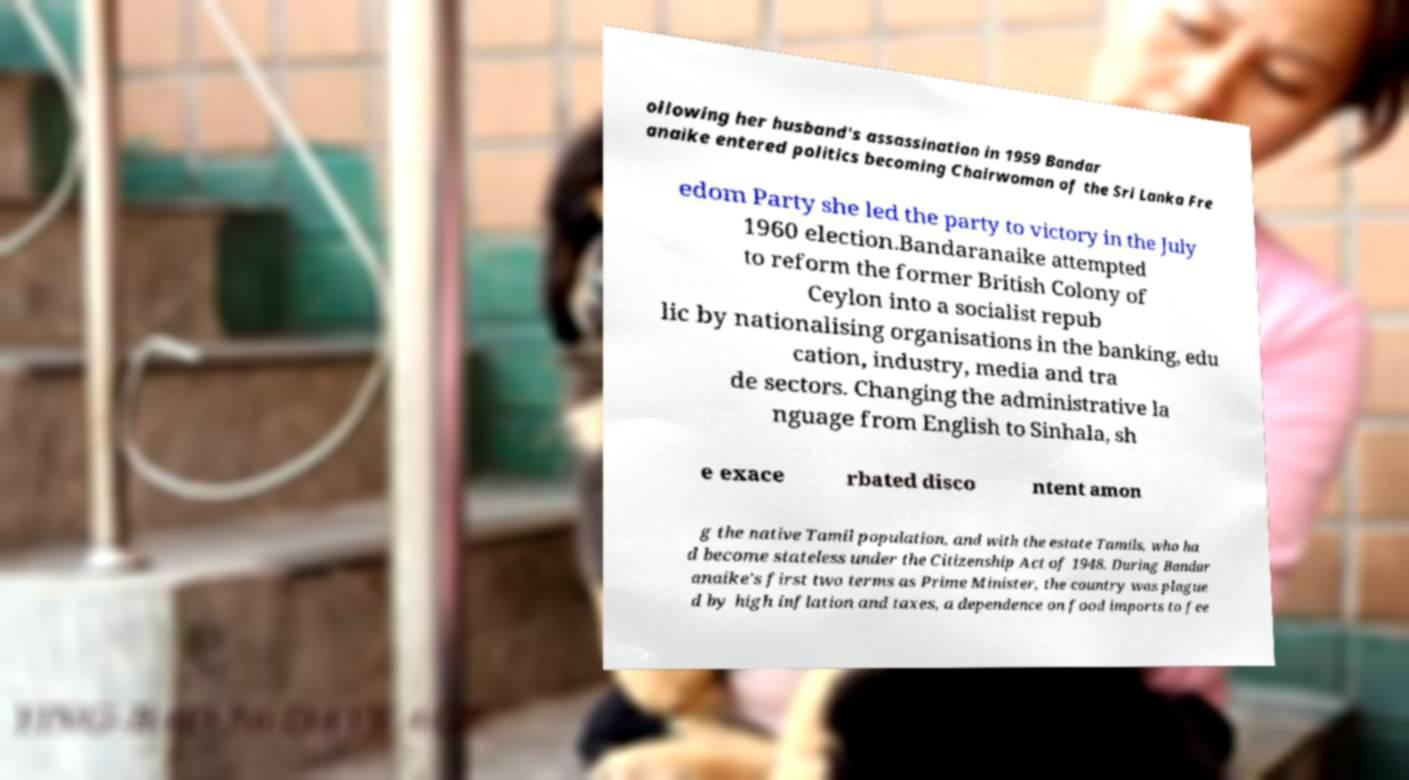There's text embedded in this image that I need extracted. Can you transcribe it verbatim? ollowing her husband's assassination in 1959 Bandar anaike entered politics becoming Chairwoman of the Sri Lanka Fre edom Party she led the party to victory in the July 1960 election.Bandaranaike attempted to reform the former British Colony of Ceylon into a socialist repub lic by nationalising organisations in the banking, edu cation, industry, media and tra de sectors. Changing the administrative la nguage from English to Sinhala, sh e exace rbated disco ntent amon g the native Tamil population, and with the estate Tamils, who ha d become stateless under the Citizenship Act of 1948. During Bandar anaike's first two terms as Prime Minister, the country was plague d by high inflation and taxes, a dependence on food imports to fee 